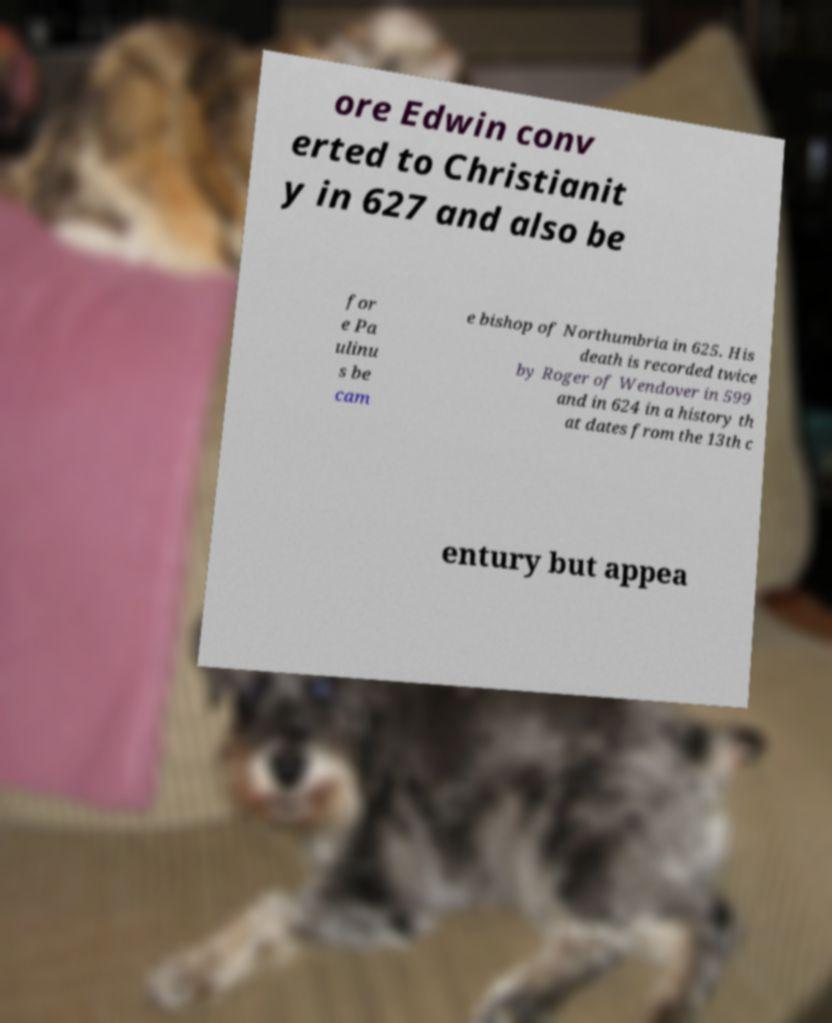Please identify and transcribe the text found in this image. ore Edwin conv erted to Christianit y in 627 and also be for e Pa ulinu s be cam e bishop of Northumbria in 625. His death is recorded twice by Roger of Wendover in 599 and in 624 in a history th at dates from the 13th c entury but appea 